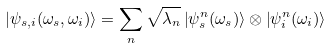Convert formula to latex. <formula><loc_0><loc_0><loc_500><loc_500>\left | \psi _ { s , i } ( \omega _ { s } , \omega _ { i } ) \right \rangle = \sum _ { n } \sqrt { \lambda _ { n } } \left | \psi _ { s } ^ { n } ( \omega _ { s } ) \right \rangle \otimes \left | \psi _ { i } ^ { n } ( \omega _ { i } ) \right \rangle</formula> 